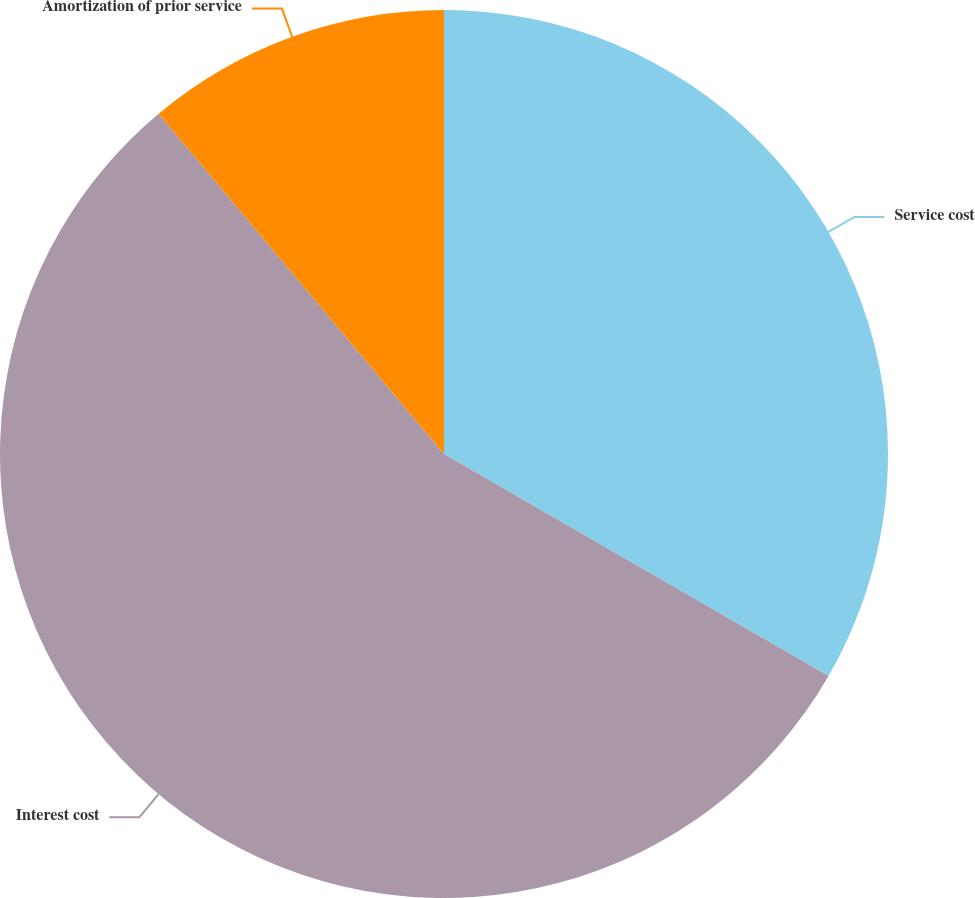Convert chart to OTSL. <chart><loc_0><loc_0><loc_500><loc_500><pie_chart><fcel>Service cost<fcel>Interest cost<fcel>Amortization of prior service<nl><fcel>33.33%<fcel>55.56%<fcel>11.11%<nl></chart> 